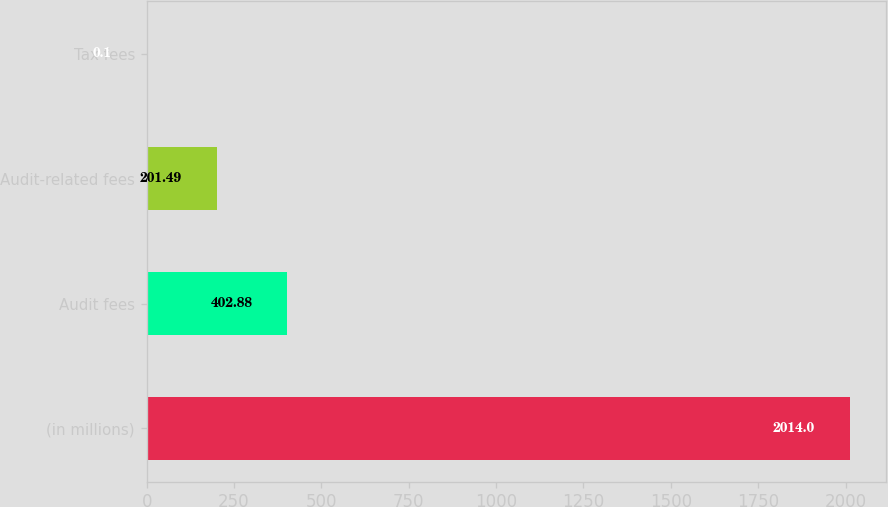Convert chart. <chart><loc_0><loc_0><loc_500><loc_500><bar_chart><fcel>(in millions)<fcel>Audit fees<fcel>Audit-related fees<fcel>Tax fees<nl><fcel>2014<fcel>402.88<fcel>201.49<fcel>0.1<nl></chart> 